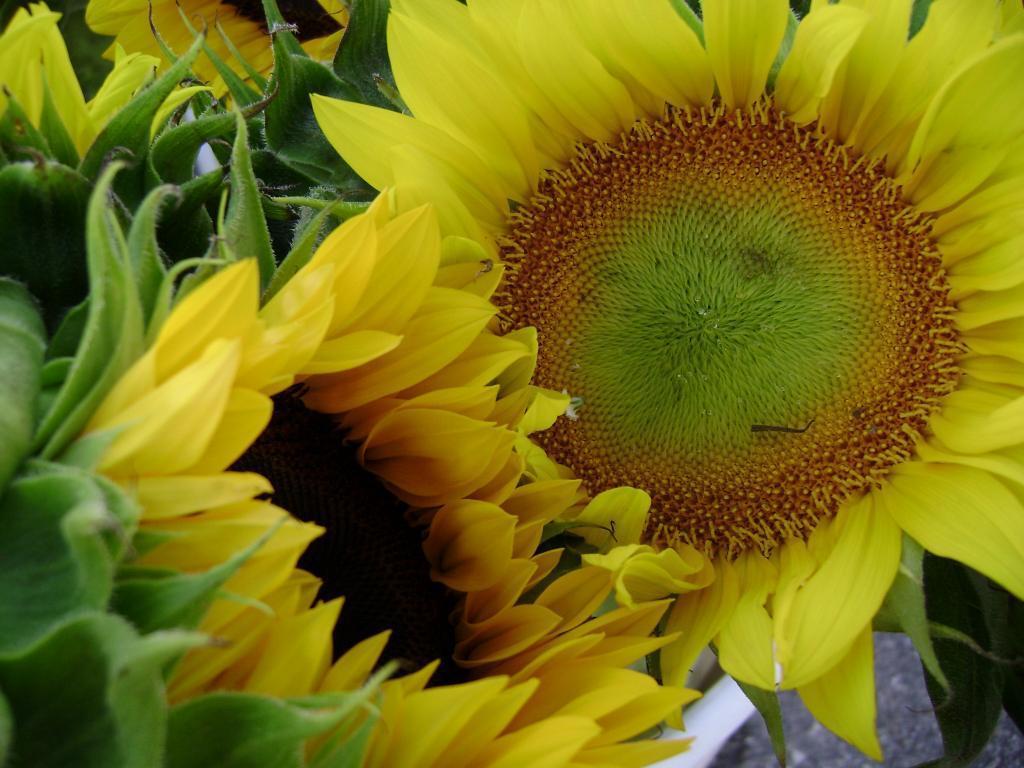Describe this image in one or two sentences. In front of the picture, we see the sunflowers in yellow color. On the left side, we see the green color sepals. In the background, we see the flowers in yellow color. 